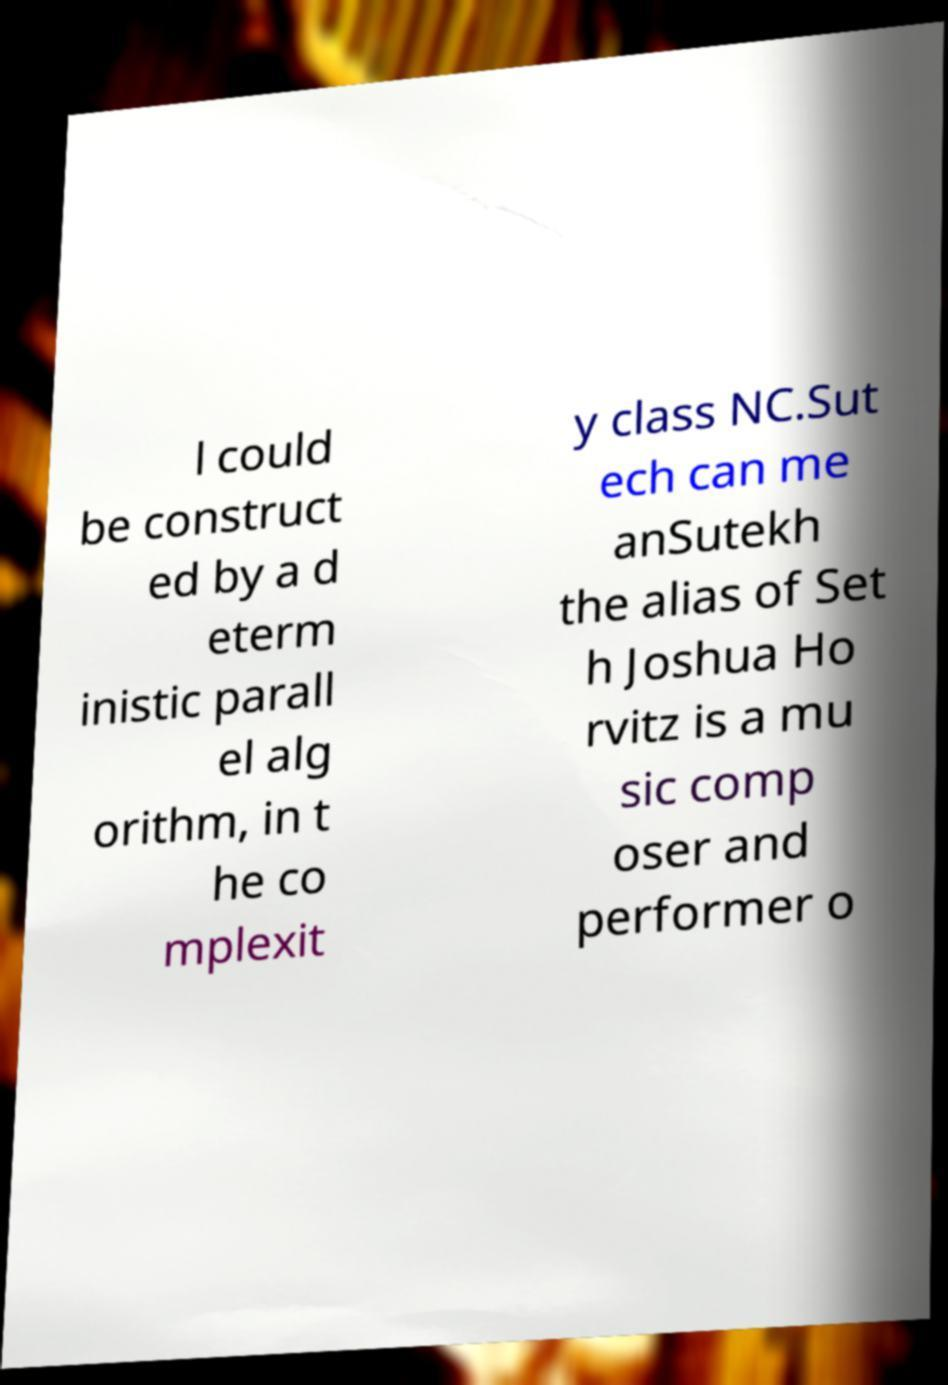What messages or text are displayed in this image? I need them in a readable, typed format. l could be construct ed by a d eterm inistic parall el alg orithm, in t he co mplexit y class NC.Sut ech can me anSutekh the alias of Set h Joshua Ho rvitz is a mu sic comp oser and performer o 